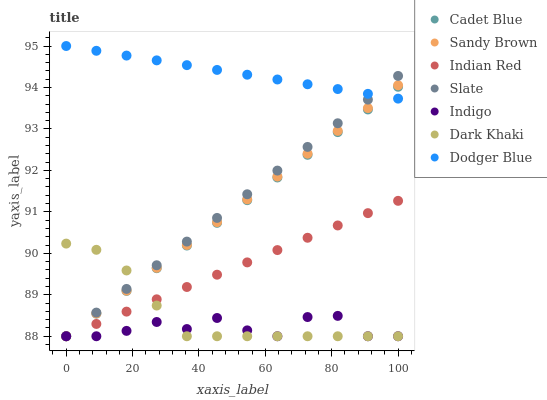Does Indigo have the minimum area under the curve?
Answer yes or no. Yes. Does Dodger Blue have the maximum area under the curve?
Answer yes or no. Yes. Does Slate have the minimum area under the curve?
Answer yes or no. No. Does Slate have the maximum area under the curve?
Answer yes or no. No. Is Dodger Blue the smoothest?
Answer yes or no. Yes. Is Indigo the roughest?
Answer yes or no. Yes. Is Slate the smoothest?
Answer yes or no. No. Is Slate the roughest?
Answer yes or no. No. Does Cadet Blue have the lowest value?
Answer yes or no. Yes. Does Dodger Blue have the lowest value?
Answer yes or no. No. Does Dodger Blue have the highest value?
Answer yes or no. Yes. Does Slate have the highest value?
Answer yes or no. No. Is Indigo less than Dodger Blue?
Answer yes or no. Yes. Is Dodger Blue greater than Dark Khaki?
Answer yes or no. Yes. Does Indigo intersect Cadet Blue?
Answer yes or no. Yes. Is Indigo less than Cadet Blue?
Answer yes or no. No. Is Indigo greater than Cadet Blue?
Answer yes or no. No. Does Indigo intersect Dodger Blue?
Answer yes or no. No. 